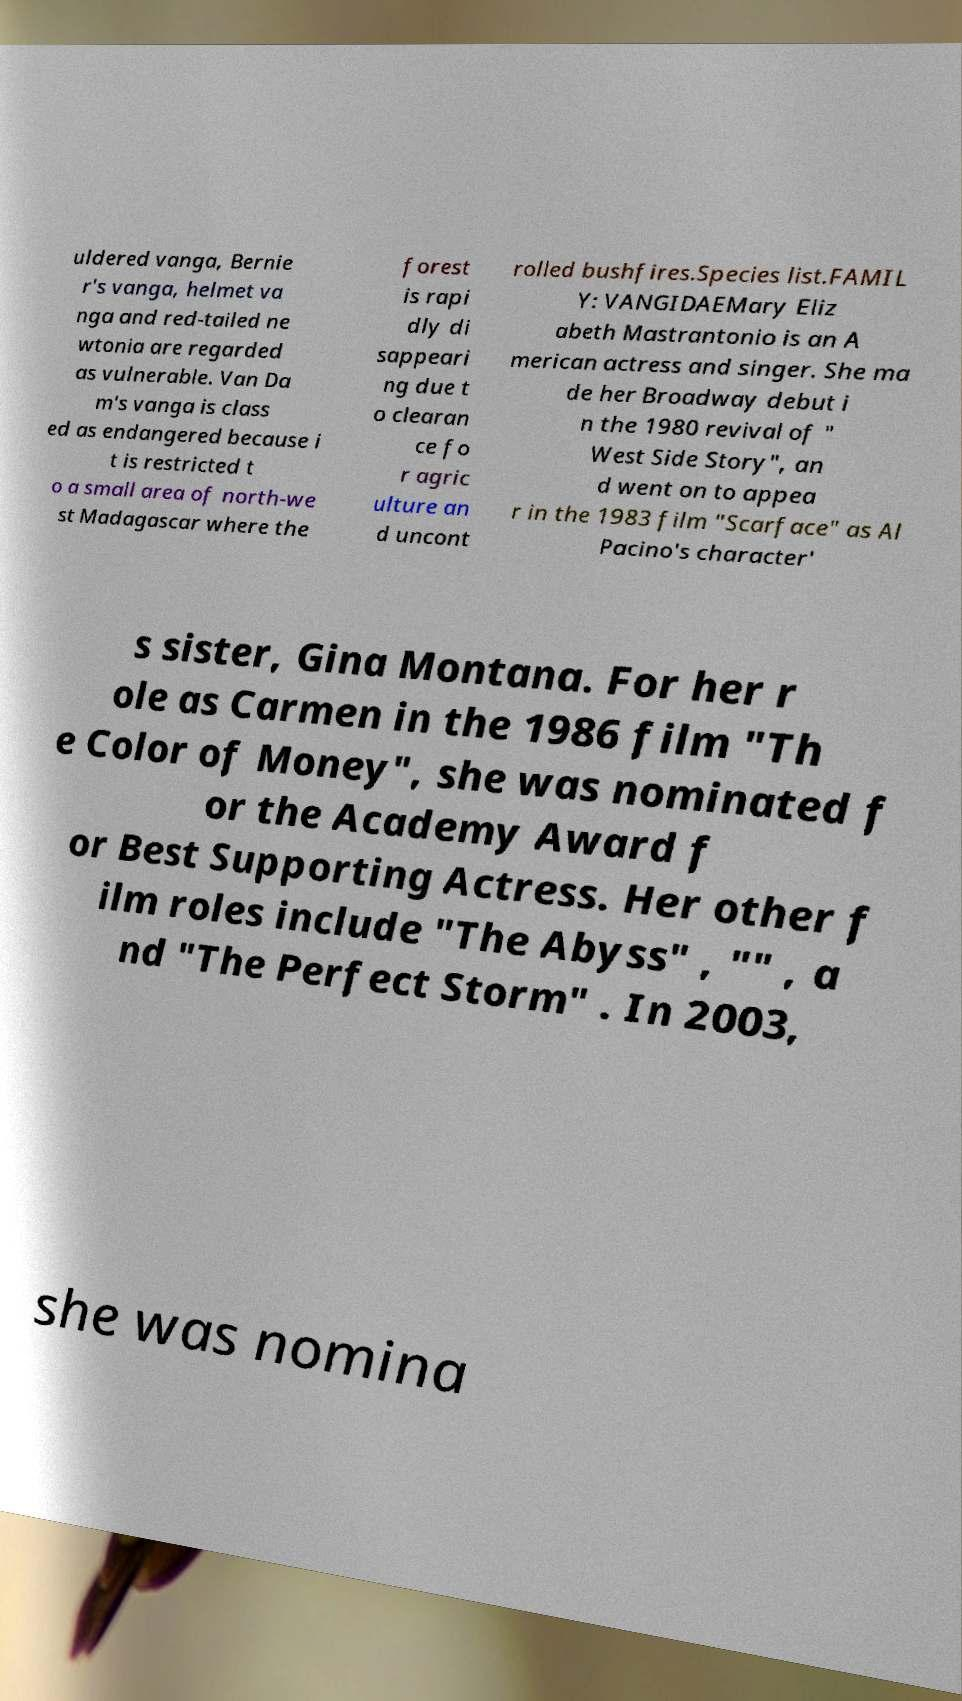I need the written content from this picture converted into text. Can you do that? uldered vanga, Bernie r's vanga, helmet va nga and red-tailed ne wtonia are regarded as vulnerable. Van Da m's vanga is class ed as endangered because i t is restricted t o a small area of north-we st Madagascar where the forest is rapi dly di sappeari ng due t o clearan ce fo r agric ulture an d uncont rolled bushfires.Species list.FAMIL Y: VANGIDAEMary Eliz abeth Mastrantonio is an A merican actress and singer. She ma de her Broadway debut i n the 1980 revival of " West Side Story", an d went on to appea r in the 1983 film "Scarface" as Al Pacino's character' s sister, Gina Montana. For her r ole as Carmen in the 1986 film "Th e Color of Money", she was nominated f or the Academy Award f or Best Supporting Actress. Her other f ilm roles include "The Abyss" , "" , a nd "The Perfect Storm" . In 2003, she was nomina 